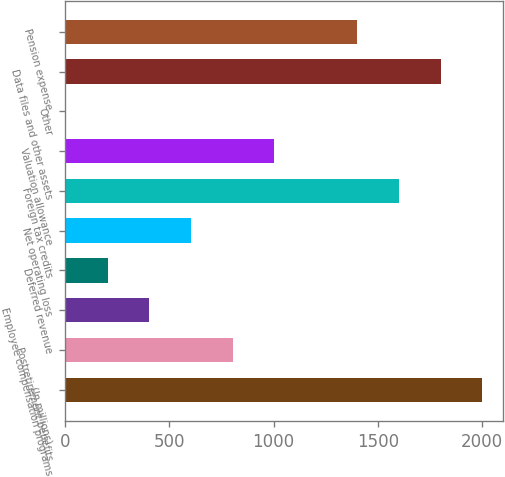<chart> <loc_0><loc_0><loc_500><loc_500><bar_chart><fcel>(In millions)<fcel>Postretirement benefits<fcel>Employee compensation programs<fcel>Deferred revenue<fcel>Net operating loss<fcel>Foreign tax credits<fcel>Valuation allowance<fcel>Other<fcel>Data files and other assets<fcel>Pension expense<nl><fcel>2001<fcel>803.16<fcel>403.88<fcel>204.24<fcel>603.52<fcel>1601.72<fcel>1002.8<fcel>4.6<fcel>1801.36<fcel>1402.08<nl></chart> 